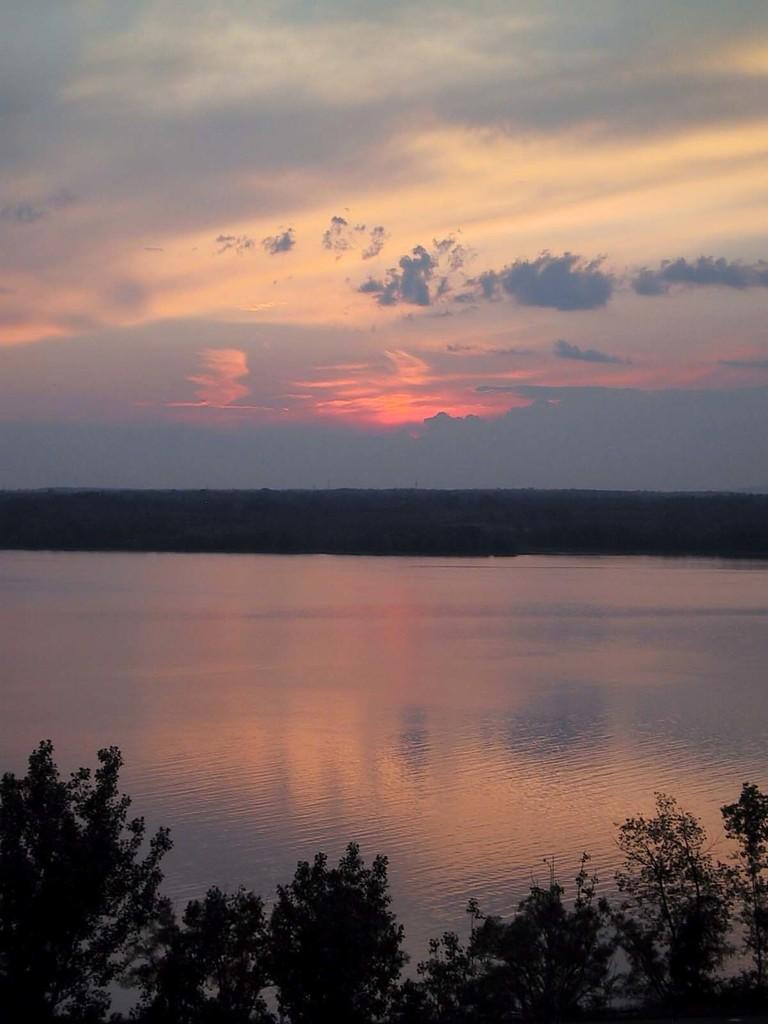What type of vegetation is at the bottom of the image? There are trees at the bottom of the image. What is located behind the trees? There is water behind the trees. What is visible at the top of the image? The sky is visible at the top of the image. What can be seen in the sky? Clouds are present in the sky. How long does the scene in the image last in minutes? The image is a still representation and does not have a duration in minutes. What type of bone can be seen in the image? There is no bone present in the image. 